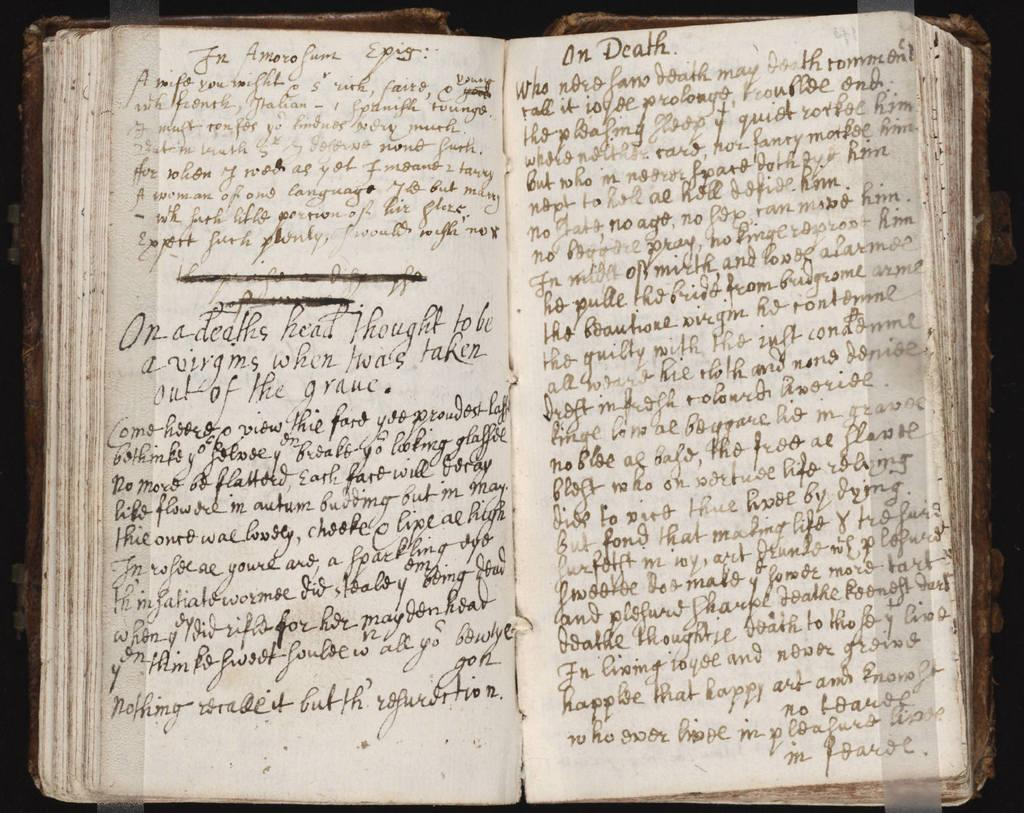What object can be seen in the image? There is a book in the image. What can be found on the pages of the book? There is text visible in the image. What type of cough can be heard from the book in the image? There is no cough present in the image; it is a book with text. What scientific principles are being discussed in the book in the image? The image does not provide enough information to determine the content of the book, so we cannot determine if any scientific principles are being discussed. 